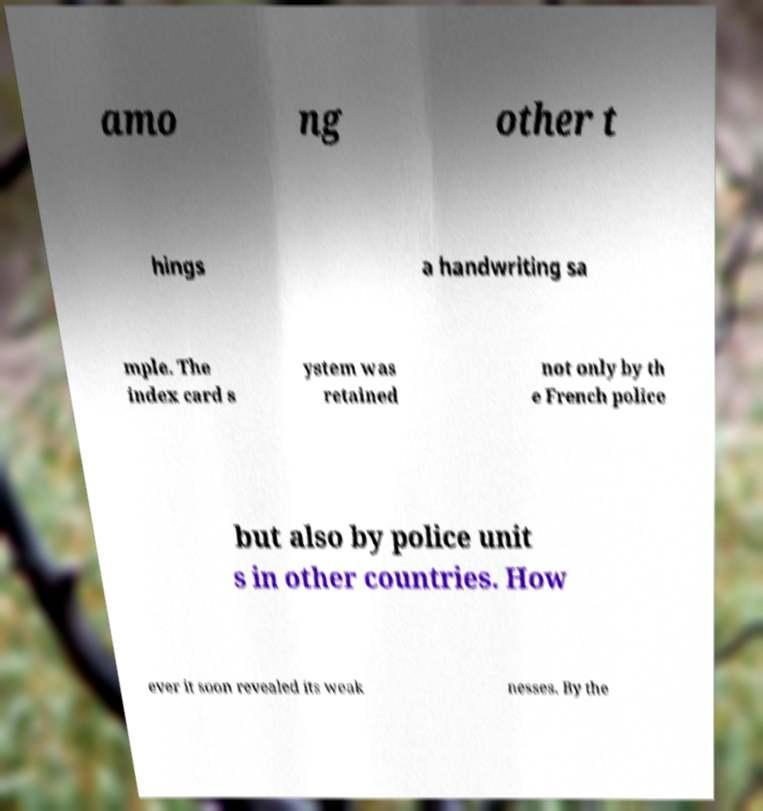For documentation purposes, I need the text within this image transcribed. Could you provide that? amo ng other t hings a handwriting sa mple. The index card s ystem was retained not only by th e French police but also by police unit s in other countries. How ever it soon revealed its weak nesses. By the 